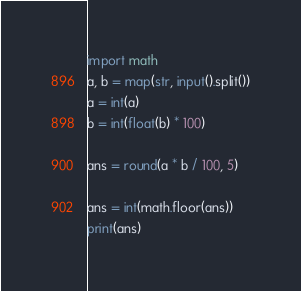<code> <loc_0><loc_0><loc_500><loc_500><_Python_>import math
a, b = map(str, input().split())
a = int(a)
b = int(float(b) * 100)

ans = round(a * b / 100, 5)

ans = int(math.floor(ans))
print(ans)</code> 